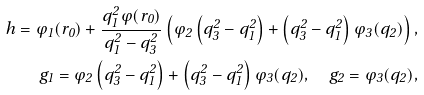<formula> <loc_0><loc_0><loc_500><loc_500>h = \varphi _ { 1 } ( r _ { 0 } ) + \frac { q _ { 1 } ^ { 2 } \varphi ( r _ { 0 } ) } { q _ { 1 } ^ { 2 } - q _ { 3 } ^ { 2 } } \left ( \varphi _ { 2 } \left ( q _ { 3 } ^ { 2 } - q _ { 1 } ^ { 2 } \right ) + \left ( q _ { 3 } ^ { 2 } - q _ { 1 } ^ { 2 } \right ) \varphi _ { 3 } ( q _ { 2 } ) \right ) , \\ g _ { 1 } = \varphi _ { 2 } \left ( q _ { 3 } ^ { 2 } - q _ { 1 } ^ { 2 } \right ) + \left ( q _ { 3 } ^ { 2 } - q _ { 1 } ^ { 2 } \right ) \varphi _ { 3 } ( q _ { 2 } ) , \quad g _ { 2 } = \varphi _ { 3 } ( q _ { 2 } ) ,</formula> 